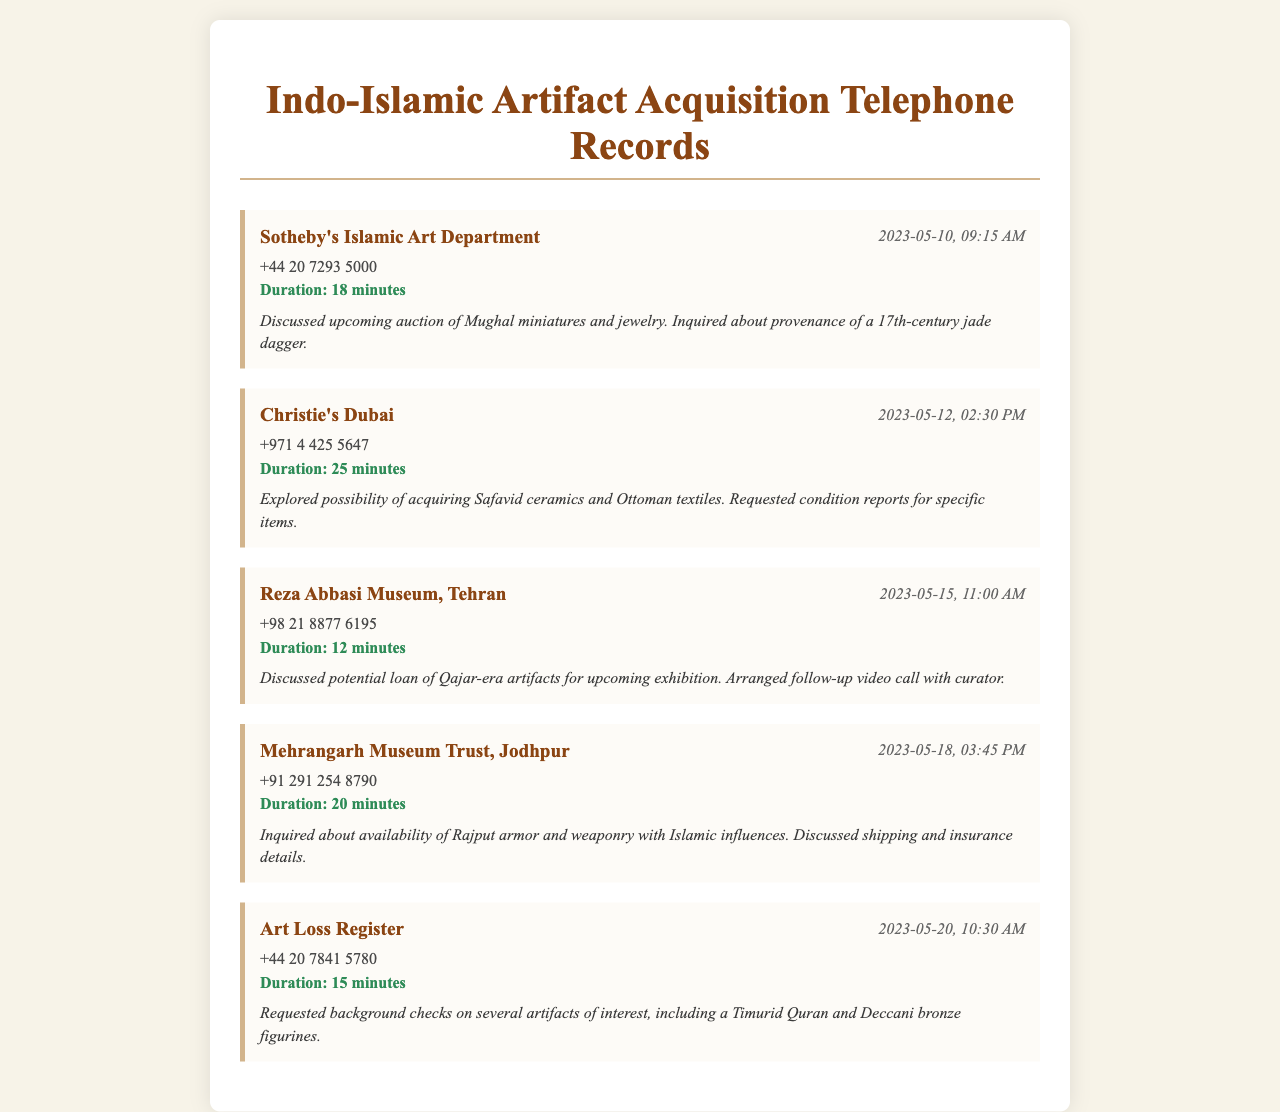What is the name of the first contacted department? The first contact in the records is with Sotheby's Islamic Art Department.
Answer: Sotheby's Islamic Art Department What was the duration of the call with Christie's Dubai? The call with Christie's Dubai lasted 25 minutes.
Answer: 25 minutes What item was discussed during the call with the Reza Abbasi Museum? The discussion included the potential loan of Qajar-era artifacts.
Answer: Qajar-era artifacts On what date was the call to the Art Loss Register made? The call to the Art Loss Register was made on May 20, 2023.
Answer: 2023-05-20 Which museum trust was contacted in Jodhpur? The contacted museum trust in Jodhpur is the Mehrangarh Museum Trust.
Answer: Mehrangarh Museum Trust What condition was requested for specific items from Christie's Dubai? Requested condition reports for specific items were discussed.
Answer: Condition reports How long was the call with Sotheby's? The duration of the call with Sotheby's was 18 minutes.
Answer: 18 minutes What type of artifacts were inquired about regarding Rajput influences? An inquiry was made about Rajput armor and weaponry with Islamic influences.
Answer: Rajput armor and weaponry 